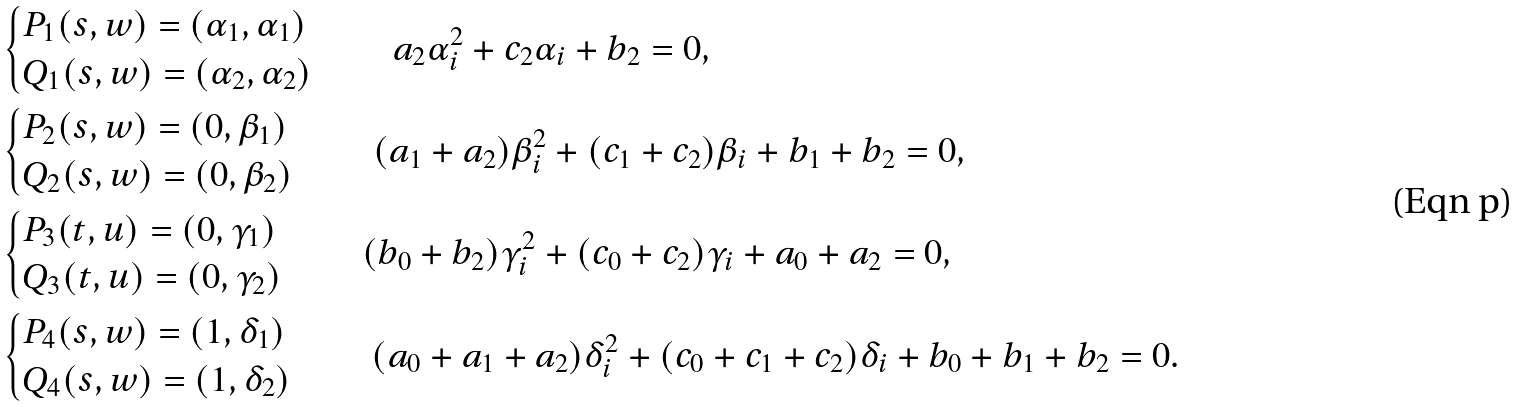Convert formula to latex. <formula><loc_0><loc_0><loc_500><loc_500>& \begin{cases} P _ { 1 } ( s , w ) = ( \alpha _ { 1 } , \alpha _ { 1 } ) \\ Q _ { 1 } ( s , w ) = ( \alpha _ { 2 } , \alpha _ { 2 } ) \end{cases} \quad a _ { 2 } \alpha _ { i } ^ { 2 } + c _ { 2 } \alpha _ { i } + b _ { 2 } = 0 , \\ & \begin{cases} P _ { 2 } ( s , w ) = ( 0 , \beta _ { 1 } ) \\ Q _ { 2 } ( s , w ) = ( 0 , \beta _ { 2 } ) \end{cases} \quad ( a _ { 1 } + a _ { 2 } ) \beta _ { i } ^ { 2 } + ( c _ { 1 } + c _ { 2 } ) \beta _ { i } + b _ { 1 } + b _ { 2 } = 0 , \\ & \begin{cases} P _ { 3 } ( t , u ) = ( 0 , \gamma _ { 1 } ) \\ Q _ { 3 } ( t , u ) = ( 0 , \gamma _ { 2 } ) \end{cases} \quad ( b _ { 0 } + b _ { 2 } ) \gamma _ { i } ^ { 2 } + ( c _ { 0 } + c _ { 2 } ) \gamma _ { i } + a _ { 0 } + a _ { 2 } = 0 , \\ & \begin{cases} P _ { 4 } ( s , w ) = ( 1 , \delta _ { 1 } ) \\ Q _ { 4 } ( s , w ) = ( 1 , \delta _ { 2 } ) \end{cases} \quad ( a _ { 0 } + a _ { 1 } + a _ { 2 } ) \delta _ { i } ^ { 2 } + ( c _ { 0 } + c _ { 1 } + c _ { 2 } ) \delta _ { i } + b _ { 0 } + b _ { 1 } + b _ { 2 } = 0 .</formula> 